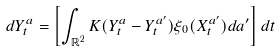<formula> <loc_0><loc_0><loc_500><loc_500>d Y _ { t } ^ { a } = \left [ \int _ { \mathbb { R } ^ { 2 } } K ( Y _ { t } ^ { a } - Y _ { t } ^ { a ^ { \prime } } ) \xi _ { 0 } ( X _ { t } ^ { a ^ { \prime } } ) d a ^ { \prime } \right ] d t</formula> 